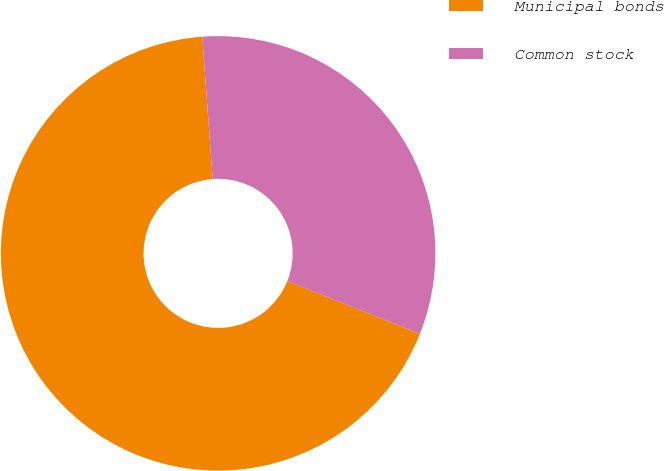<chart> <loc_0><loc_0><loc_500><loc_500><pie_chart><fcel>Municipal bonds<fcel>Common stock<nl><fcel>67.79%<fcel>32.21%<nl></chart> 